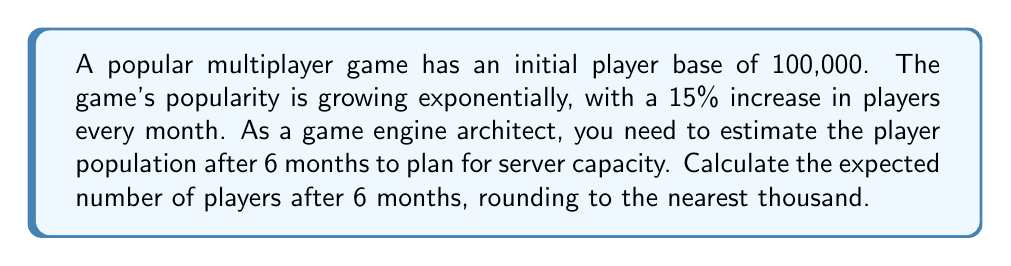Can you answer this question? Let's approach this step-by-step:

1) The initial population is 100,000 players.
2) The growth rate is 15% per month, or 0.15 in decimal form.
3) We need to calculate the population after 6 months.

We can use the exponential growth formula:

$$A = P(1 + r)^t$$

Where:
$A$ = Final amount
$P$ = Initial principal balance
$r$ = Growth rate (in decimal form)
$t$ = Number of time periods

Plugging in our values:

$$A = 100,000(1 + 0.15)^6$$

Now let's calculate:

$$\begin{align}
A &= 100,000(1.15)^6 \\
&= 100,000(2.3131112) \\
&= 231,311.12
\end{align}$$

Rounding to the nearest thousand:

$$A \approx 231,000$$

This means that after 6 months, we can expect approximately 231,000 players.

As a game engine architect, you would need to ensure that your server infrastructure can handle this increased load, potentially by implementing scalable architecture or cloud-based solutions.
Answer: 231,000 players 